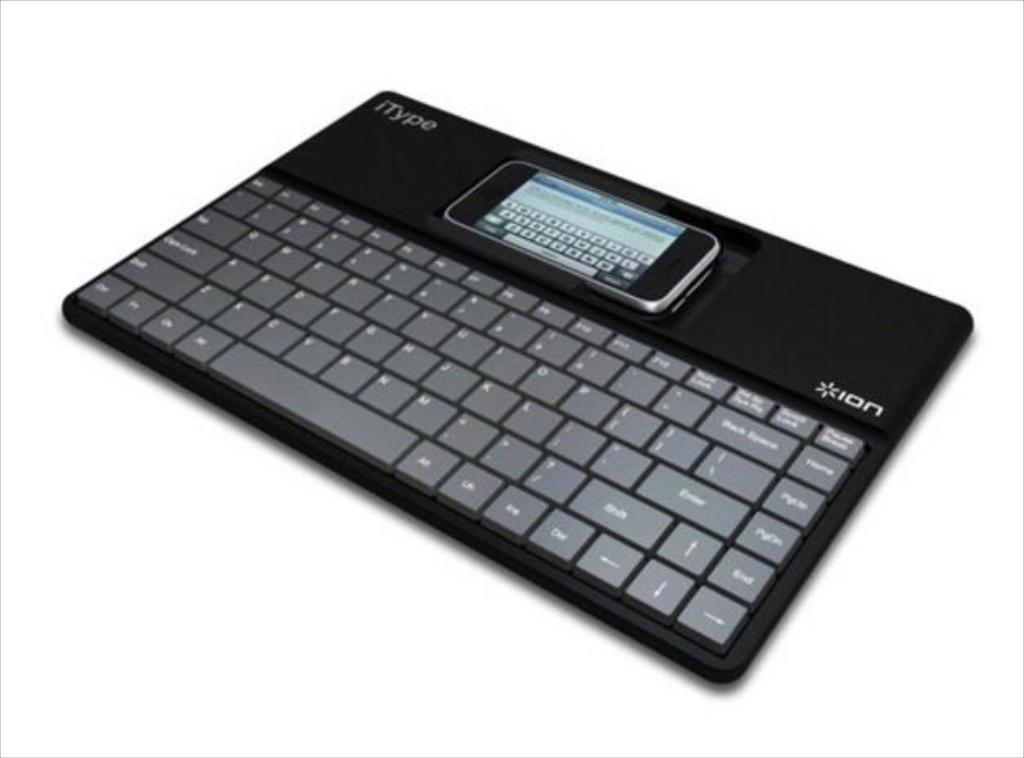Provide a one-sentence caption for the provided image. The itype keyboard helps you type messages on your smartphone. 